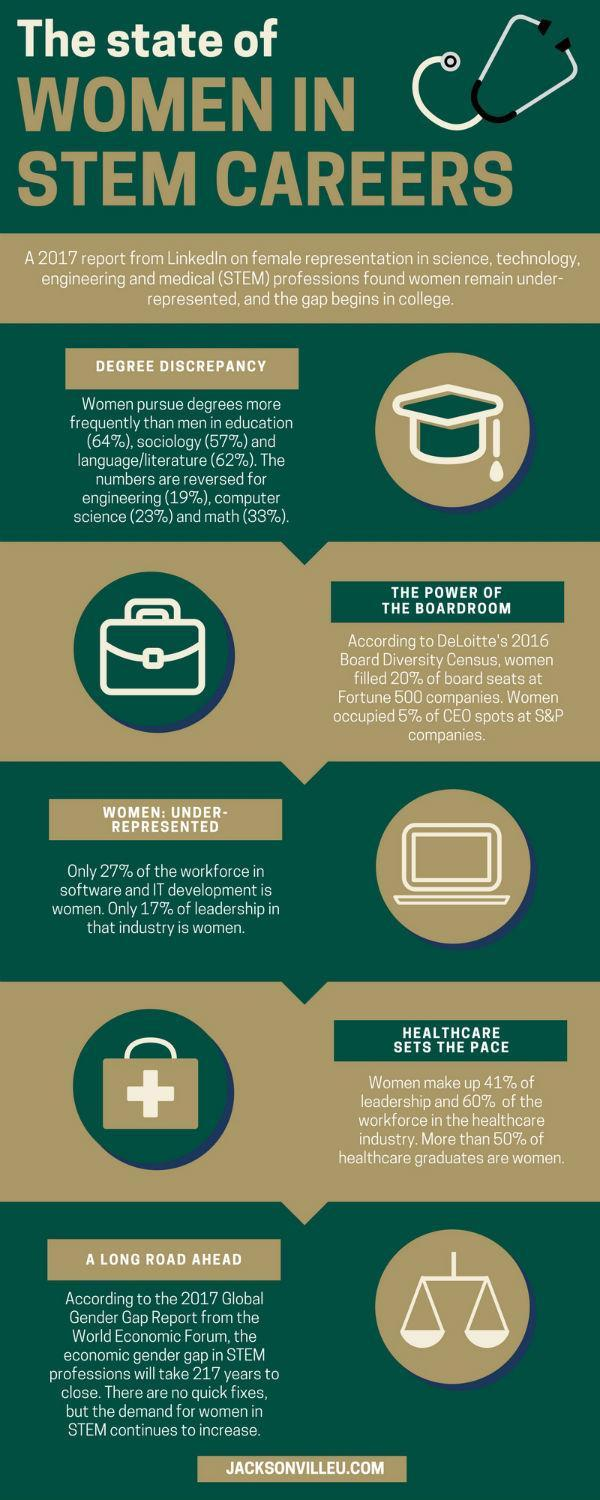What percentage of board seats at Fortune 500 companies are not women?
Answer the question with a short phrase. 80% What percentage of the workforce in the healthcare industry is not women? 40% What percentage of CEO spots at S&P companies are not occupied by women? 95% What percentage of the leadership in the healthcare industry is not women? 59% What percentage of the workforce in software and IT development, not women? 73% 